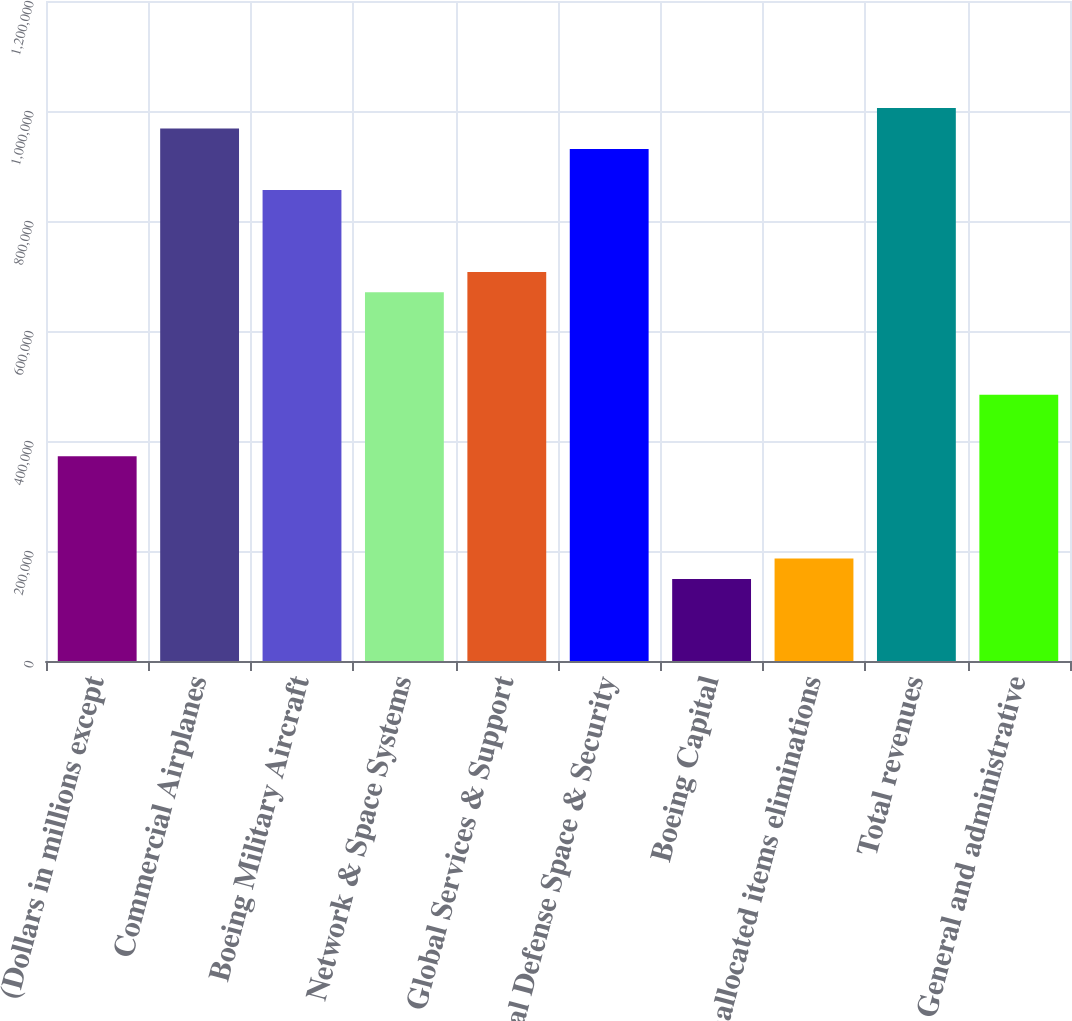Convert chart. <chart><loc_0><loc_0><loc_500><loc_500><bar_chart><fcel>(Dollars in millions except<fcel>Commercial Airplanes<fcel>Boeing Military Aircraft<fcel>Network & Space Systems<fcel>Global Services & Support<fcel>Total Defense Space & Security<fcel>Boeing Capital<fcel>Unallocated items eliminations<fcel>Total revenues<fcel>General and administrative<nl><fcel>372355<fcel>968120<fcel>856414<fcel>670238<fcel>707473<fcel>930885<fcel>148943<fcel>186178<fcel>1.00536e+06<fcel>484061<nl></chart> 